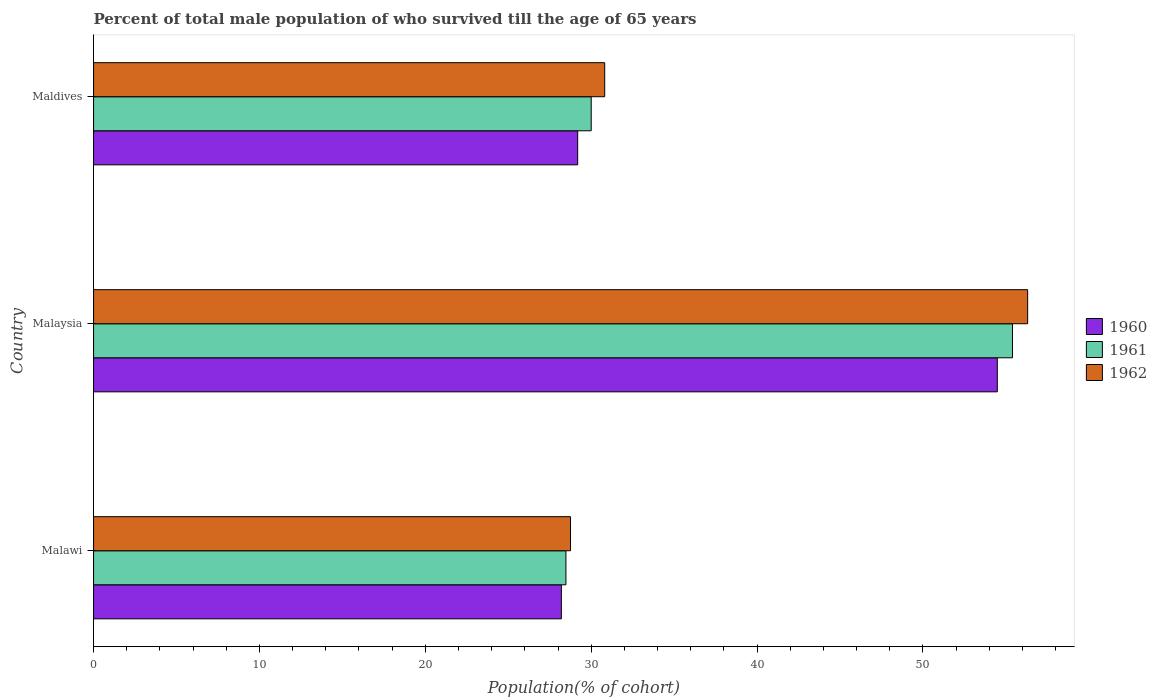How many groups of bars are there?
Offer a very short reply. 3. Are the number of bars per tick equal to the number of legend labels?
Your answer should be compact. Yes. Are the number of bars on each tick of the Y-axis equal?
Your answer should be very brief. Yes. How many bars are there on the 2nd tick from the top?
Offer a very short reply. 3. What is the label of the 2nd group of bars from the top?
Keep it short and to the point. Malaysia. What is the percentage of total male population who survived till the age of 65 years in 1962 in Malaysia?
Make the answer very short. 56.31. Across all countries, what is the maximum percentage of total male population who survived till the age of 65 years in 1961?
Your response must be concise. 55.4. Across all countries, what is the minimum percentage of total male population who survived till the age of 65 years in 1962?
Offer a terse response. 28.75. In which country was the percentage of total male population who survived till the age of 65 years in 1961 maximum?
Offer a very short reply. Malaysia. In which country was the percentage of total male population who survived till the age of 65 years in 1960 minimum?
Ensure brevity in your answer.  Malawi. What is the total percentage of total male population who survived till the age of 65 years in 1961 in the graph?
Keep it short and to the point. 113.88. What is the difference between the percentage of total male population who survived till the age of 65 years in 1960 in Malaysia and that in Maldives?
Give a very brief answer. 25.3. What is the difference between the percentage of total male population who survived till the age of 65 years in 1961 in Malawi and the percentage of total male population who survived till the age of 65 years in 1962 in Malaysia?
Your response must be concise. -27.84. What is the average percentage of total male population who survived till the age of 65 years in 1960 per country?
Your answer should be compact. 37.29. What is the difference between the percentage of total male population who survived till the age of 65 years in 1962 and percentage of total male population who survived till the age of 65 years in 1960 in Malawi?
Provide a short and direct response. 0.55. What is the ratio of the percentage of total male population who survived till the age of 65 years in 1960 in Malaysia to that in Maldives?
Ensure brevity in your answer.  1.87. Is the percentage of total male population who survived till the age of 65 years in 1960 in Malawi less than that in Maldives?
Offer a very short reply. Yes. Is the difference between the percentage of total male population who survived till the age of 65 years in 1962 in Malawi and Maldives greater than the difference between the percentage of total male population who survived till the age of 65 years in 1960 in Malawi and Maldives?
Your answer should be very brief. No. What is the difference between the highest and the second highest percentage of total male population who survived till the age of 65 years in 1961?
Offer a terse response. 25.4. What is the difference between the highest and the lowest percentage of total male population who survived till the age of 65 years in 1961?
Make the answer very short. 26.92. What does the 2nd bar from the top in Malawi represents?
Offer a very short reply. 1961. How many bars are there?
Keep it short and to the point. 9. What is the difference between two consecutive major ticks on the X-axis?
Provide a short and direct response. 10. Does the graph contain any zero values?
Offer a terse response. No. How are the legend labels stacked?
Your answer should be very brief. Vertical. What is the title of the graph?
Offer a terse response. Percent of total male population of who survived till the age of 65 years. Does "1986" appear as one of the legend labels in the graph?
Give a very brief answer. No. What is the label or title of the X-axis?
Make the answer very short. Population(% of cohort). What is the label or title of the Y-axis?
Your answer should be very brief. Country. What is the Population(% of cohort) in 1960 in Malawi?
Offer a terse response. 28.2. What is the Population(% of cohort) in 1961 in Malawi?
Offer a very short reply. 28.48. What is the Population(% of cohort) in 1962 in Malawi?
Your answer should be compact. 28.75. What is the Population(% of cohort) of 1960 in Malaysia?
Provide a succinct answer. 54.48. What is the Population(% of cohort) in 1961 in Malaysia?
Your response must be concise. 55.4. What is the Population(% of cohort) of 1962 in Malaysia?
Provide a short and direct response. 56.31. What is the Population(% of cohort) in 1960 in Maldives?
Keep it short and to the point. 29.19. What is the Population(% of cohort) of 1961 in Maldives?
Ensure brevity in your answer.  30. What is the Population(% of cohort) of 1962 in Maldives?
Offer a very short reply. 30.81. Across all countries, what is the maximum Population(% of cohort) in 1960?
Your answer should be very brief. 54.48. Across all countries, what is the maximum Population(% of cohort) in 1961?
Ensure brevity in your answer.  55.4. Across all countries, what is the maximum Population(% of cohort) of 1962?
Ensure brevity in your answer.  56.31. Across all countries, what is the minimum Population(% of cohort) in 1960?
Provide a succinct answer. 28.2. Across all countries, what is the minimum Population(% of cohort) in 1961?
Give a very brief answer. 28.48. Across all countries, what is the minimum Population(% of cohort) of 1962?
Ensure brevity in your answer.  28.75. What is the total Population(% of cohort) in 1960 in the graph?
Your answer should be very brief. 111.87. What is the total Population(% of cohort) in 1961 in the graph?
Give a very brief answer. 113.88. What is the total Population(% of cohort) of 1962 in the graph?
Your answer should be compact. 115.88. What is the difference between the Population(% of cohort) of 1960 in Malawi and that in Malaysia?
Your answer should be compact. -26.28. What is the difference between the Population(% of cohort) in 1961 in Malawi and that in Malaysia?
Your answer should be very brief. -26.92. What is the difference between the Population(% of cohort) of 1962 in Malawi and that in Malaysia?
Your answer should be compact. -27.56. What is the difference between the Population(% of cohort) of 1960 in Malawi and that in Maldives?
Provide a succinct answer. -0.98. What is the difference between the Population(% of cohort) of 1961 in Malawi and that in Maldives?
Offer a very short reply. -1.52. What is the difference between the Population(% of cohort) in 1962 in Malawi and that in Maldives?
Provide a short and direct response. -2.06. What is the difference between the Population(% of cohort) in 1960 in Malaysia and that in Maldives?
Your response must be concise. 25.3. What is the difference between the Population(% of cohort) of 1961 in Malaysia and that in Maldives?
Ensure brevity in your answer.  25.4. What is the difference between the Population(% of cohort) of 1962 in Malaysia and that in Maldives?
Offer a very short reply. 25.5. What is the difference between the Population(% of cohort) of 1960 in Malawi and the Population(% of cohort) of 1961 in Malaysia?
Ensure brevity in your answer.  -27.2. What is the difference between the Population(% of cohort) in 1960 in Malawi and the Population(% of cohort) in 1962 in Malaysia?
Give a very brief answer. -28.11. What is the difference between the Population(% of cohort) in 1961 in Malawi and the Population(% of cohort) in 1962 in Malaysia?
Ensure brevity in your answer.  -27.84. What is the difference between the Population(% of cohort) in 1960 in Malawi and the Population(% of cohort) in 1961 in Maldives?
Your response must be concise. -1.8. What is the difference between the Population(% of cohort) of 1960 in Malawi and the Population(% of cohort) of 1962 in Maldives?
Ensure brevity in your answer.  -2.61. What is the difference between the Population(% of cohort) of 1961 in Malawi and the Population(% of cohort) of 1962 in Maldives?
Offer a very short reply. -2.34. What is the difference between the Population(% of cohort) of 1960 in Malaysia and the Population(% of cohort) of 1961 in Maldives?
Your answer should be very brief. 24.48. What is the difference between the Population(% of cohort) of 1960 in Malaysia and the Population(% of cohort) of 1962 in Maldives?
Make the answer very short. 23.67. What is the difference between the Population(% of cohort) in 1961 in Malaysia and the Population(% of cohort) in 1962 in Maldives?
Offer a very short reply. 24.58. What is the average Population(% of cohort) in 1960 per country?
Offer a very short reply. 37.29. What is the average Population(% of cohort) of 1961 per country?
Ensure brevity in your answer.  37.96. What is the average Population(% of cohort) in 1962 per country?
Offer a terse response. 38.63. What is the difference between the Population(% of cohort) in 1960 and Population(% of cohort) in 1961 in Malawi?
Keep it short and to the point. -0.28. What is the difference between the Population(% of cohort) of 1960 and Population(% of cohort) of 1962 in Malawi?
Keep it short and to the point. -0.55. What is the difference between the Population(% of cohort) of 1961 and Population(% of cohort) of 1962 in Malawi?
Offer a terse response. -0.28. What is the difference between the Population(% of cohort) of 1960 and Population(% of cohort) of 1961 in Malaysia?
Keep it short and to the point. -0.92. What is the difference between the Population(% of cohort) in 1960 and Population(% of cohort) in 1962 in Malaysia?
Your answer should be very brief. -1.83. What is the difference between the Population(% of cohort) of 1961 and Population(% of cohort) of 1962 in Malaysia?
Your response must be concise. -0.92. What is the difference between the Population(% of cohort) of 1960 and Population(% of cohort) of 1961 in Maldives?
Offer a terse response. -0.81. What is the difference between the Population(% of cohort) of 1960 and Population(% of cohort) of 1962 in Maldives?
Keep it short and to the point. -1.63. What is the difference between the Population(% of cohort) in 1961 and Population(% of cohort) in 1962 in Maldives?
Ensure brevity in your answer.  -0.81. What is the ratio of the Population(% of cohort) in 1960 in Malawi to that in Malaysia?
Keep it short and to the point. 0.52. What is the ratio of the Population(% of cohort) of 1961 in Malawi to that in Malaysia?
Give a very brief answer. 0.51. What is the ratio of the Population(% of cohort) in 1962 in Malawi to that in Malaysia?
Make the answer very short. 0.51. What is the ratio of the Population(% of cohort) in 1960 in Malawi to that in Maldives?
Ensure brevity in your answer.  0.97. What is the ratio of the Population(% of cohort) of 1961 in Malawi to that in Maldives?
Your answer should be very brief. 0.95. What is the ratio of the Population(% of cohort) of 1962 in Malawi to that in Maldives?
Offer a very short reply. 0.93. What is the ratio of the Population(% of cohort) of 1960 in Malaysia to that in Maldives?
Your answer should be very brief. 1.87. What is the ratio of the Population(% of cohort) of 1961 in Malaysia to that in Maldives?
Provide a succinct answer. 1.85. What is the ratio of the Population(% of cohort) of 1962 in Malaysia to that in Maldives?
Provide a short and direct response. 1.83. What is the difference between the highest and the second highest Population(% of cohort) in 1960?
Ensure brevity in your answer.  25.3. What is the difference between the highest and the second highest Population(% of cohort) of 1961?
Offer a terse response. 25.4. What is the difference between the highest and the second highest Population(% of cohort) in 1962?
Make the answer very short. 25.5. What is the difference between the highest and the lowest Population(% of cohort) in 1960?
Provide a short and direct response. 26.28. What is the difference between the highest and the lowest Population(% of cohort) in 1961?
Ensure brevity in your answer.  26.92. What is the difference between the highest and the lowest Population(% of cohort) of 1962?
Your response must be concise. 27.56. 